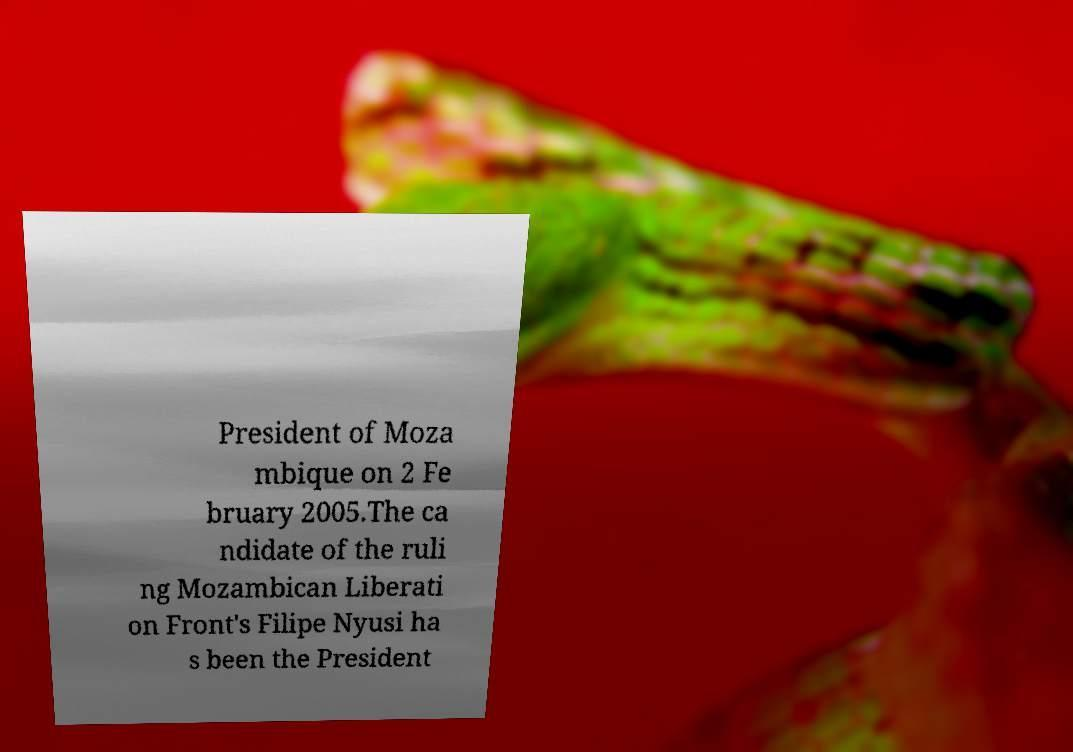Please identify and transcribe the text found in this image. President of Moza mbique on 2 Fe bruary 2005.The ca ndidate of the ruli ng Mozambican Liberati on Front's Filipe Nyusi ha s been the President 